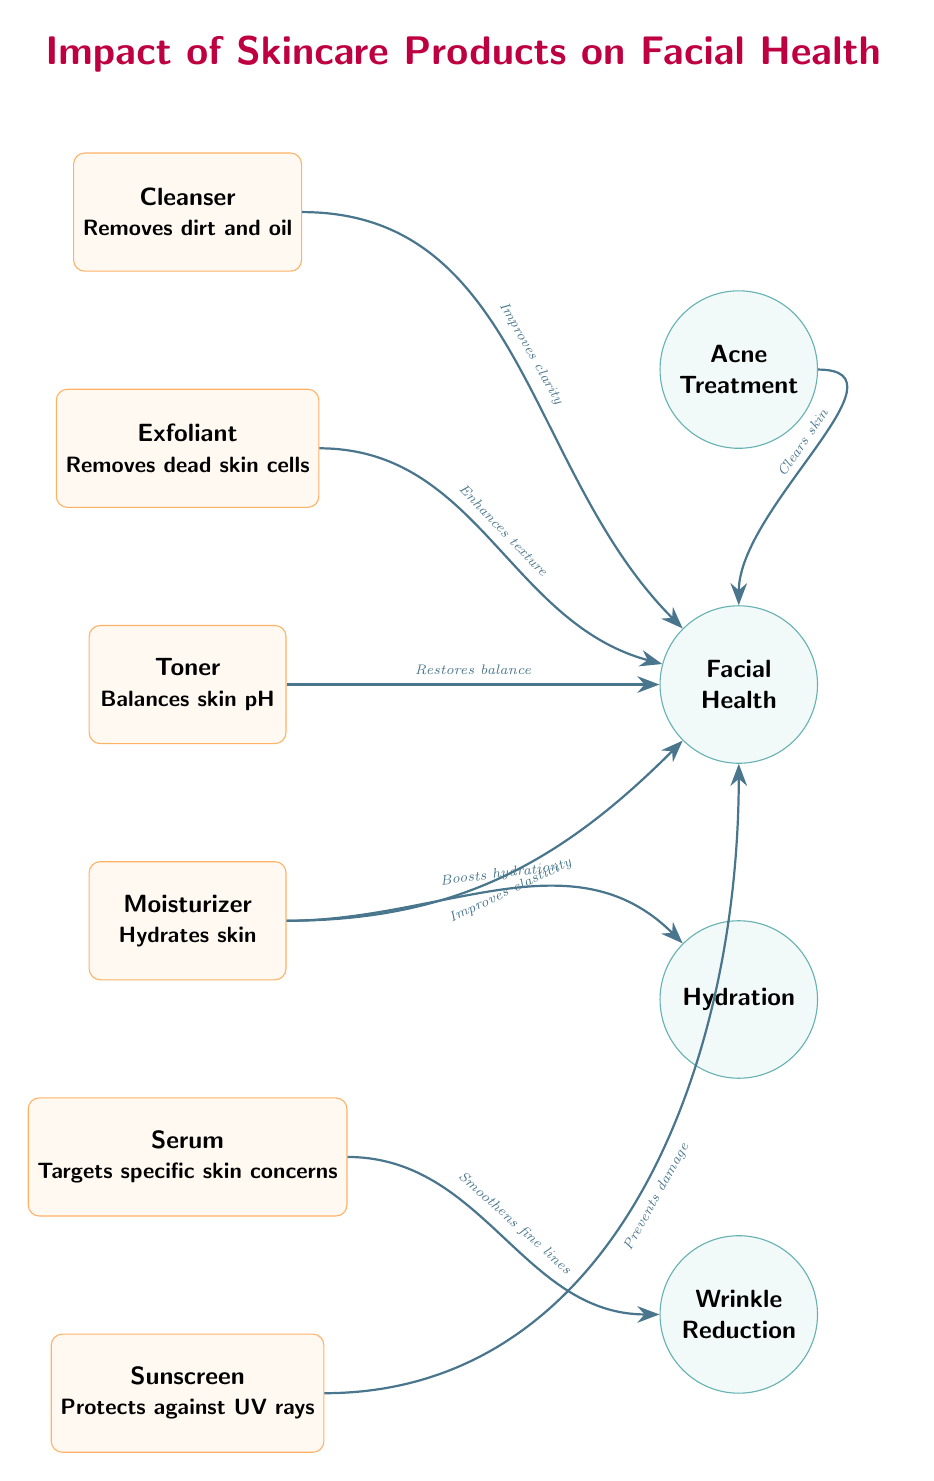What skincare product is located at the top of the diagram? The topmost node in the diagram is labeled "Cleanser," indicating it is the product situated at the highest position.
Answer: Cleanser How many skincare products are shown in the diagram? By counting the distinct product nodes, there are six products: Cleanser, Exfoliant, Toner, Moisturizer, Serum, and Sunscreen.
Answer: 6 Which product improves skin clarity? The arrow leading from the "Cleanser" node points to "Facial Health," with the label "Improves clarity," indicating that this product enhances clarity.
Answer: Cleanser What effect does the moisturizer have on hydration? The arrow from "Moisturizer" points to the "Hydration" node, labeled "Boosts hydration," indicating the specific impact of this product on hydration.
Answer: Boosts hydration Which product targets specific skin concerns? The product labeled "Serum" has a description that states it targets specific skin concerns and is linked accordingly in the diagram.
Answer: Serum What is one of the effects of using an exfoliant? The connection from "Exfoliant" to "Facial Health" is labeled "Enhances texture," indicating the positive effect of using this product.
Answer: Enhances texture Which product prevents UV damage? The arrow from "Sunscreen" points to "Facial Health," and the label states "Prevents damage," specifically identifying sunscreen's protective quality against UV rays.
Answer: Sunscreen How does toner contribute to facial health? The arrow stemming from "Toner" points to "Facial Health," labeled "Restores balance," showing its role in maintaining facial health through balancing skin pH.
Answer: Restores balance What is the relationship between moisturizer and wrinkle reduction? The "Moisturizer" connects to "Facial Health" with "Improves elasticity," which indirectly supports wrinkle reduction through improved skin structure.
Answer: Improves elasticity 